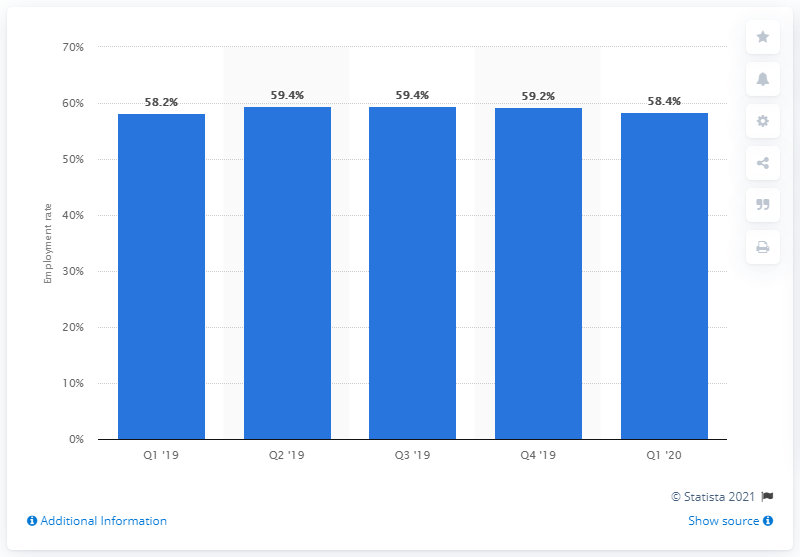Give some essential details in this illustration. The unemployment rate for foreign residents decreased by 58.4% in the first quarter of 2020. During the period of January to March 2020, the employment rate of foreigners living in Italy was 58.4%. 